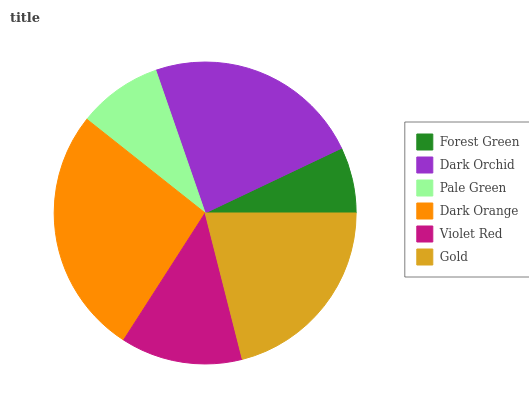Is Forest Green the minimum?
Answer yes or no. Yes. Is Dark Orange the maximum?
Answer yes or no. Yes. Is Dark Orchid the minimum?
Answer yes or no. No. Is Dark Orchid the maximum?
Answer yes or no. No. Is Dark Orchid greater than Forest Green?
Answer yes or no. Yes. Is Forest Green less than Dark Orchid?
Answer yes or no. Yes. Is Forest Green greater than Dark Orchid?
Answer yes or no. No. Is Dark Orchid less than Forest Green?
Answer yes or no. No. Is Gold the high median?
Answer yes or no. Yes. Is Violet Red the low median?
Answer yes or no. Yes. Is Pale Green the high median?
Answer yes or no. No. Is Dark Orange the low median?
Answer yes or no. No. 